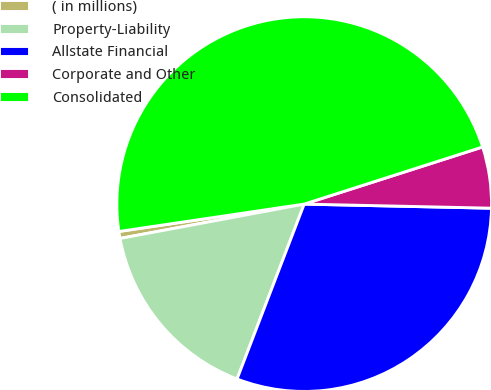Convert chart to OTSL. <chart><loc_0><loc_0><loc_500><loc_500><pie_chart><fcel>( in millions)<fcel>Property-Liability<fcel>Allstate Financial<fcel>Corporate and Other<fcel>Consolidated<nl><fcel>0.6%<fcel>16.23%<fcel>30.48%<fcel>5.28%<fcel>47.4%<nl></chart> 